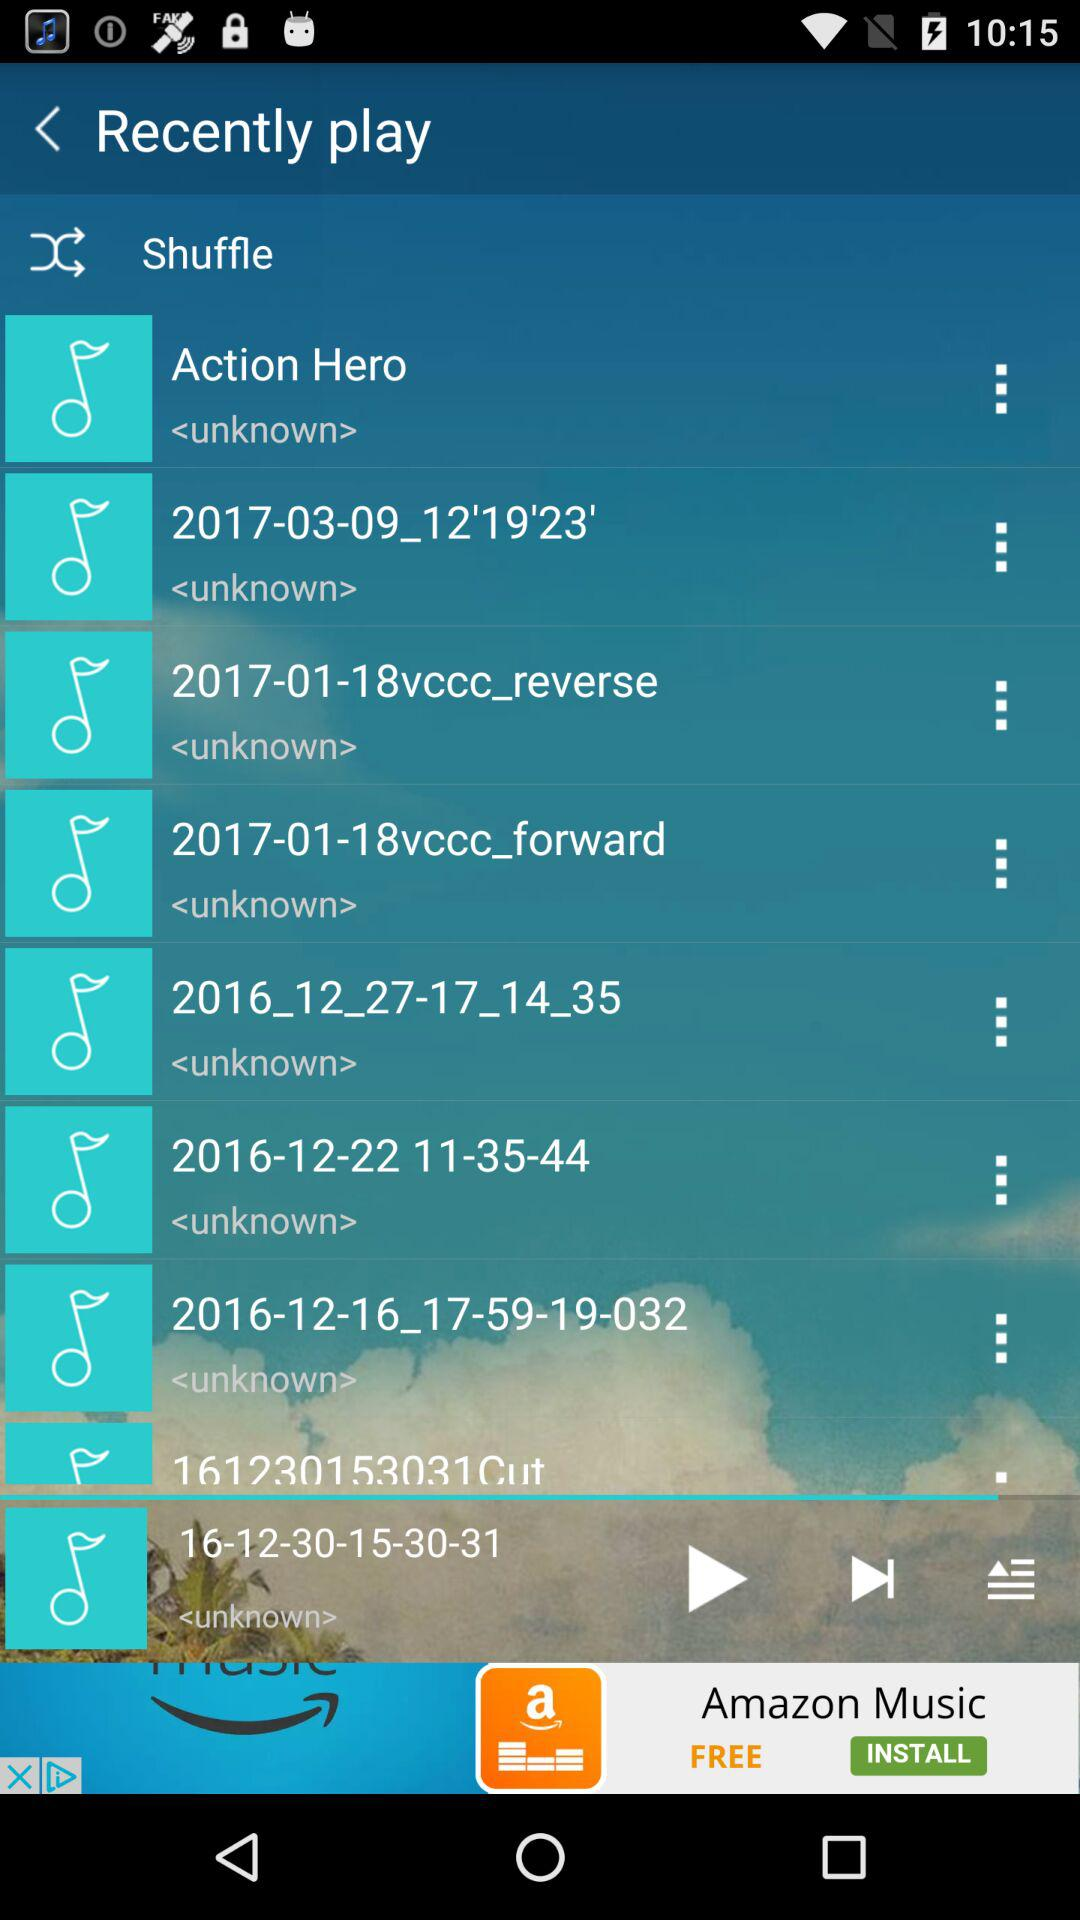Who's the singer of the Song "Action Hero"?
When the provided information is insufficient, respond with <no answer>. <no answer> 